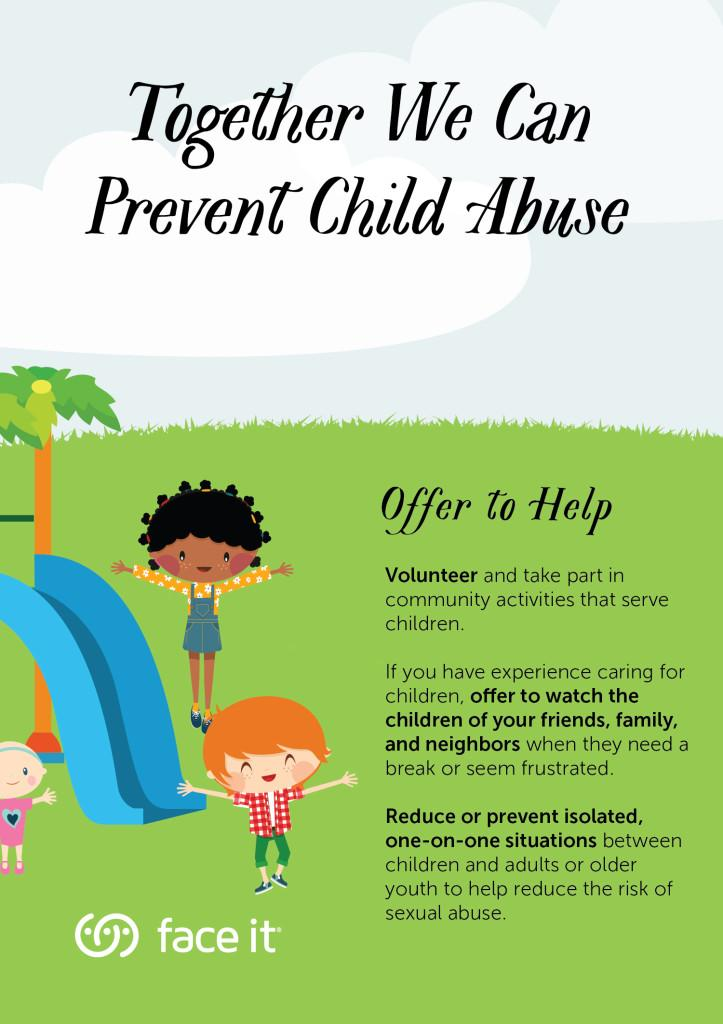Draw attention to some important aspects in this diagram. I can help friends, family, and neighbors when they are frustrated by offering to watch their children. A person experienced in childcare can seek help from friends, family, and neighbors when in need of a break. Preventing isolated situations between children and adults can minimize the risk of sexual abuse. The color of the slide is blue. It is clear that three children are present in the image. 